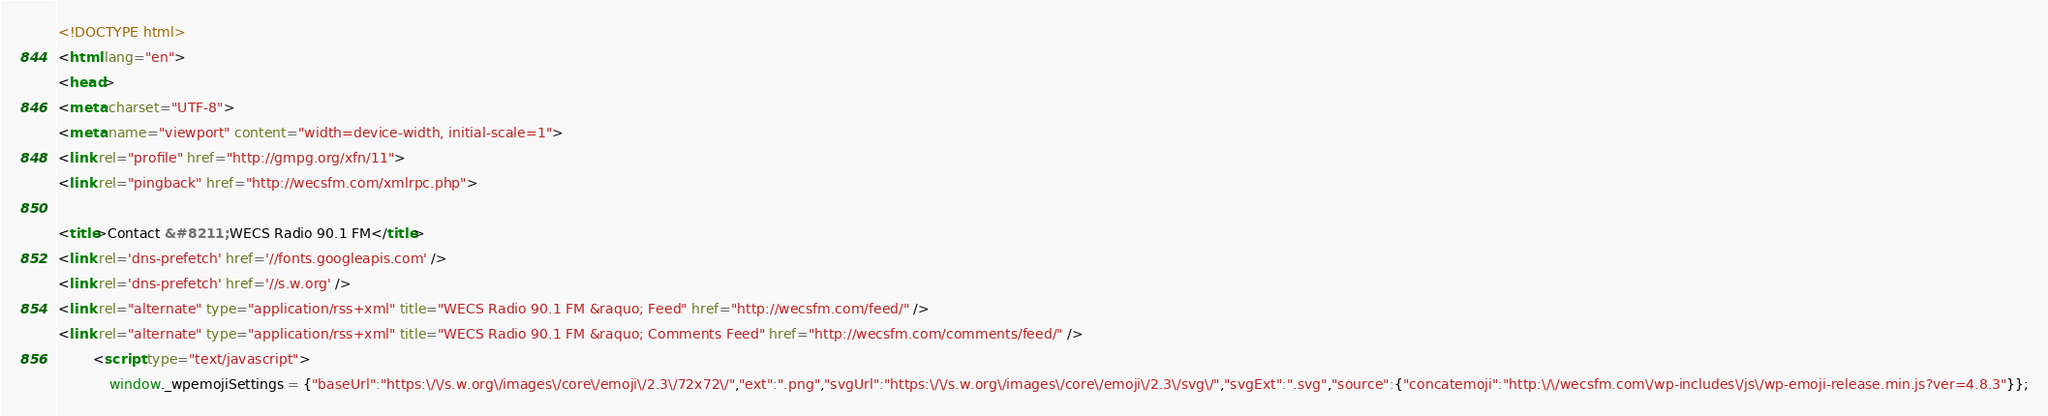<code> <loc_0><loc_0><loc_500><loc_500><_HTML_><!DOCTYPE html>
<html lang="en">
<head>
<meta charset="UTF-8">
<meta name="viewport" content="width=device-width, initial-scale=1">
<link rel="profile" href="http://gmpg.org/xfn/11">
<link rel="pingback" href="http://wecsfm.com/xmlrpc.php">

<title>Contact &#8211; WECS Radio 90.1 FM</title>
<link rel='dns-prefetch' href='//fonts.googleapis.com' />
<link rel='dns-prefetch' href='//s.w.org' />
<link rel="alternate" type="application/rss+xml" title="WECS Radio 90.1 FM &raquo; Feed" href="http://wecsfm.com/feed/" />
<link rel="alternate" type="application/rss+xml" title="WECS Radio 90.1 FM &raquo; Comments Feed" href="http://wecsfm.com/comments/feed/" />
		<script type="text/javascript">
			window._wpemojiSettings = {"baseUrl":"https:\/\/s.w.org\/images\/core\/emoji\/2.3\/72x72\/","ext":".png","svgUrl":"https:\/\/s.w.org\/images\/core\/emoji\/2.3\/svg\/","svgExt":".svg","source":{"concatemoji":"http:\/\/wecsfm.com\/wp-includes\/js\/wp-emoji-release.min.js?ver=4.8.3"}};</code> 